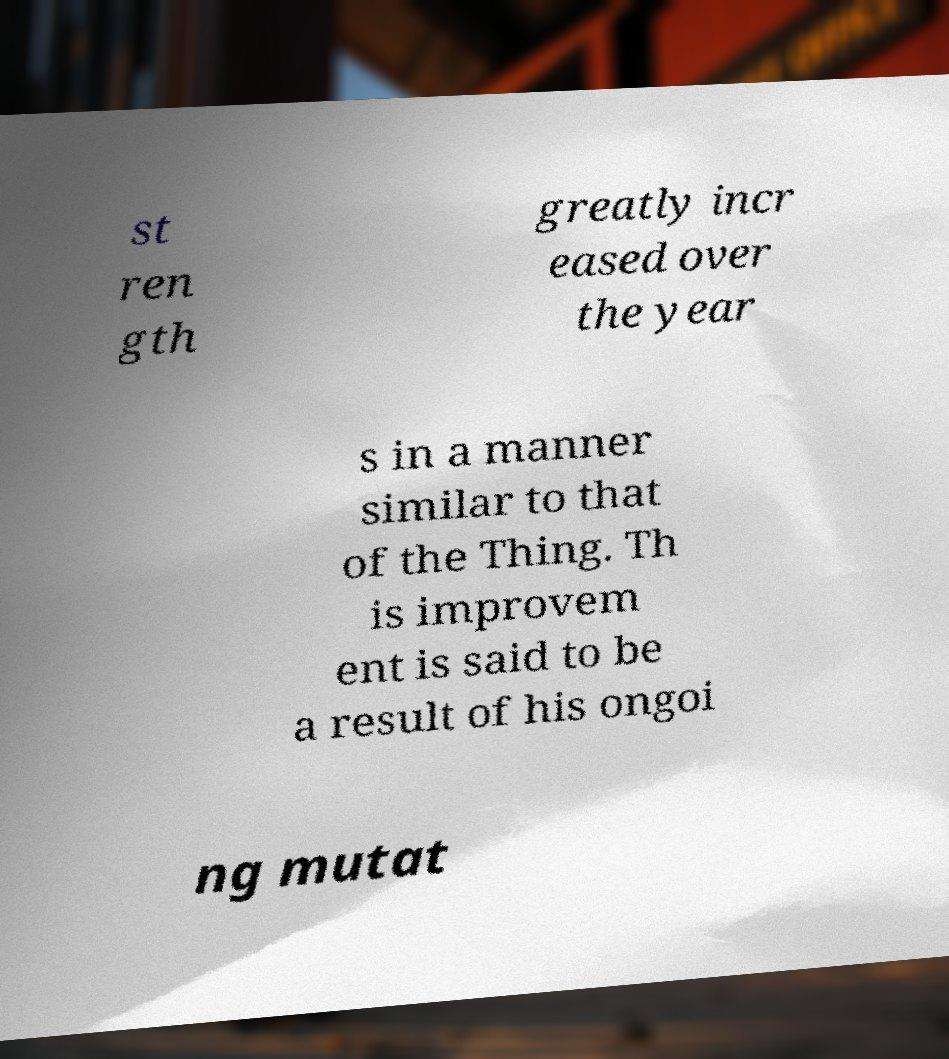I need the written content from this picture converted into text. Can you do that? st ren gth greatly incr eased over the year s in a manner similar to that of the Thing. Th is improvem ent is said to be a result of his ongoi ng mutat 